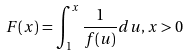Convert formula to latex. <formula><loc_0><loc_0><loc_500><loc_500>F ( x ) = \int _ { 1 } ^ { x } \frac { 1 } { f ( u ) } d u , x > 0</formula> 